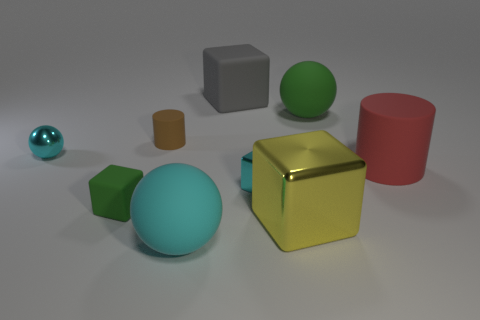Subtract all tiny green rubber blocks. How many blocks are left? 3 Add 1 tiny cyan metallic cylinders. How many objects exist? 10 Subtract all cyan blocks. How many blocks are left? 3 Subtract 2 cubes. How many cubes are left? 2 Subtract all green balls. Subtract all cyan cylinders. How many balls are left? 2 Subtract all red spheres. How many purple cylinders are left? 0 Subtract all large rubber cylinders. Subtract all large green objects. How many objects are left? 7 Add 9 gray things. How many gray things are left? 10 Add 8 gray blocks. How many gray blocks exist? 9 Subtract 0 blue cylinders. How many objects are left? 9 